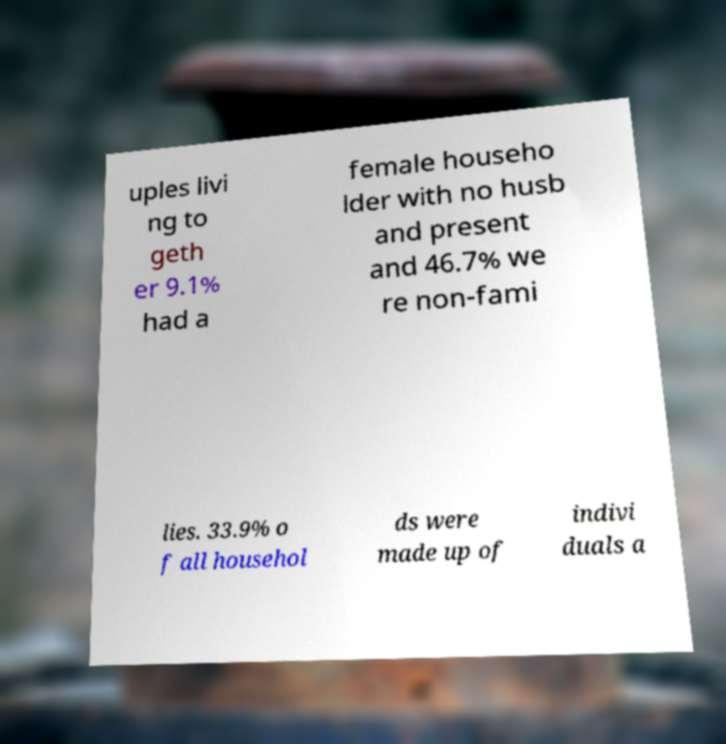What messages or text are displayed in this image? I need them in a readable, typed format. uples livi ng to geth er 9.1% had a female househo lder with no husb and present and 46.7% we re non-fami lies. 33.9% o f all househol ds were made up of indivi duals a 